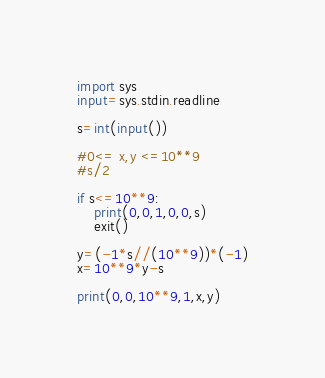Convert code to text. <code><loc_0><loc_0><loc_500><loc_500><_Python_>import sys
input=sys.stdin.readline

s=int(input())

#0<= x,y <=10**9
#s/2

if s<=10**9:
    print(0,0,1,0,0,s)
    exit()

y=(-1*s//(10**9))*(-1)
x=10**9*y-s

print(0,0,10**9,1,x,y)


</code> 